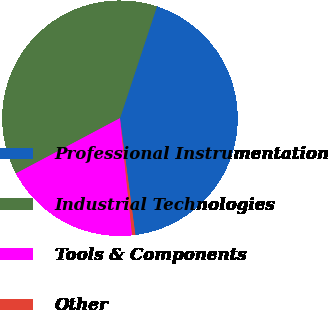<chart> <loc_0><loc_0><loc_500><loc_500><pie_chart><fcel>Professional Instrumentation<fcel>Industrial Technologies<fcel>Tools & Components<fcel>Other<nl><fcel>42.83%<fcel>37.85%<fcel>18.88%<fcel>0.44%<nl></chart> 